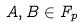<formula> <loc_0><loc_0><loc_500><loc_500>A , B \in F _ { p }</formula> 